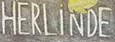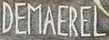What text appears in these images from left to right, separated by a semicolon? HERLiNDE; DEMAEREL 